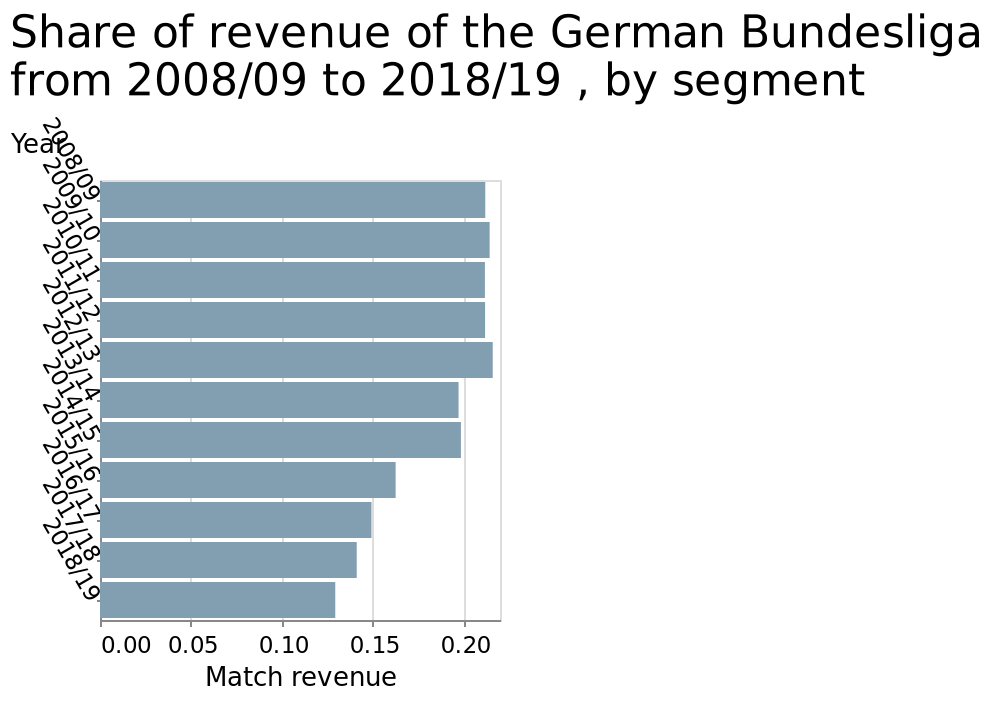<image>
What does the x-axis represent in the bar diagram?  The x-axis represents the match revenue. please enumerates aspects of the construction of the chart Here a bar diagram is labeled Share of revenue of the German Bundesliga from 2008/09 to 2018/19 , by segment. The y-axis shows Year while the x-axis measures Match revenue. 